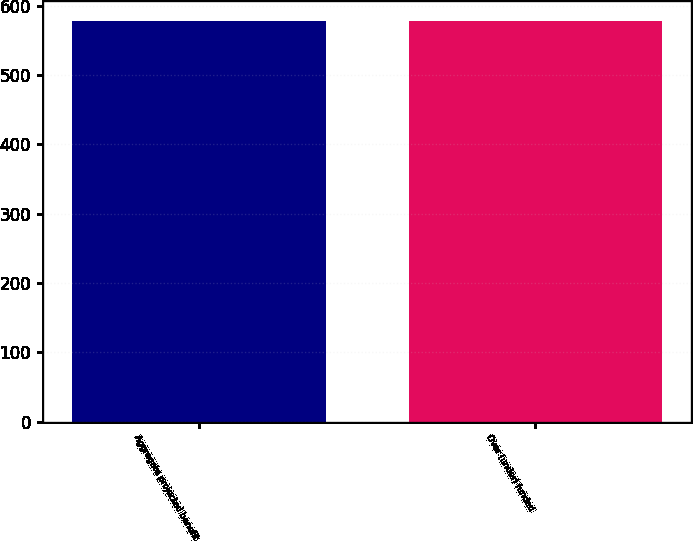Convert chart. <chart><loc_0><loc_0><loc_500><loc_500><bar_chart><fcel>Aggregate projected benefit<fcel>Over (under) funded<nl><fcel>578<fcel>578.1<nl></chart> 